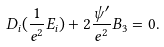Convert formula to latex. <formula><loc_0><loc_0><loc_500><loc_500>D _ { i } ( \frac { 1 } { e ^ { 2 } } E _ { i } ) + 2 \frac { \psi ^ { \prime } } { e ^ { 2 } } B _ { 3 } = 0 .</formula> 